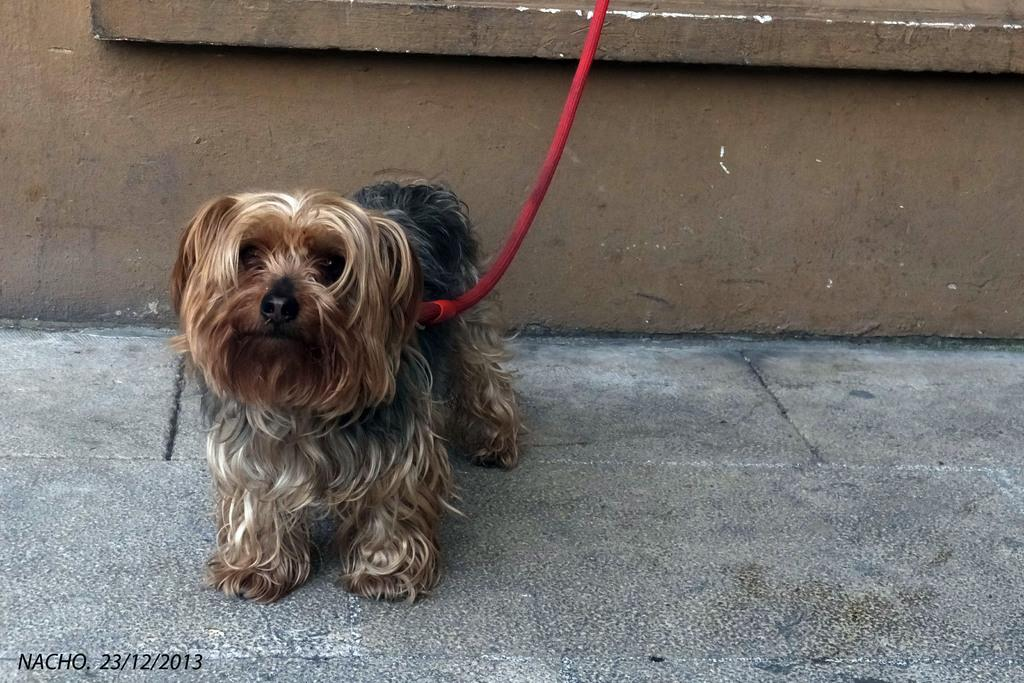What type of animal is in the image? There is a dog in the image. What colors can be seen on the dog? The dog has cream, black, and white colors. What object is present in the image that is not part of the dog? There is a red rope in the image. What color is the background wall in the image? The background wall is brown. What type of linen is being used to play volleyball in the image? There is no linen or volleyball present in the image. How many tickets can be seen in the image? There are no tickets present in the image. 